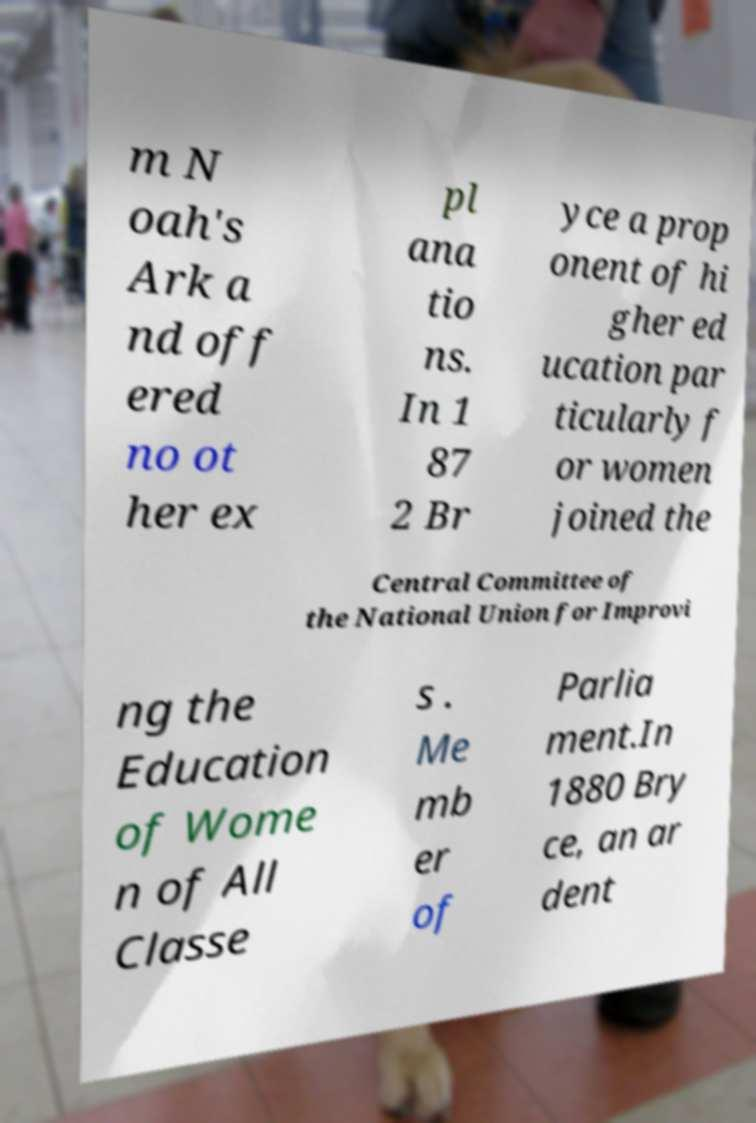For documentation purposes, I need the text within this image transcribed. Could you provide that? m N oah's Ark a nd off ered no ot her ex pl ana tio ns. In 1 87 2 Br yce a prop onent of hi gher ed ucation par ticularly f or women joined the Central Committee of the National Union for Improvi ng the Education of Wome n of All Classe s . Me mb er of Parlia ment.In 1880 Bry ce, an ar dent 